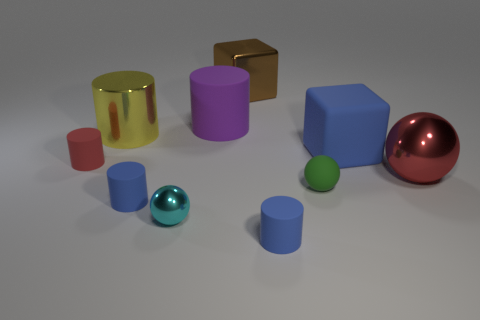Subtract 2 cylinders. How many cylinders are left? 3 Subtract all brown cylinders. Subtract all green blocks. How many cylinders are left? 5 Subtract all blocks. How many objects are left? 8 Subtract 0 gray spheres. How many objects are left? 10 Subtract all spheres. Subtract all green objects. How many objects are left? 6 Add 9 red cylinders. How many red cylinders are left? 10 Add 3 shiny cubes. How many shiny cubes exist? 4 